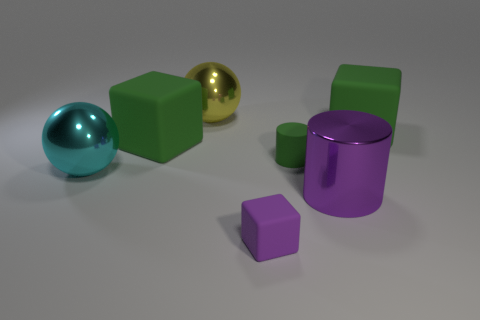There is a cube that is on the left side of the big shiny cylinder and behind the large cylinder; what is its color?
Your answer should be compact. Green. What number of green cylinders have the same size as the cyan metallic ball?
Ensure brevity in your answer.  0. What is the shape of the small thing that is behind the metallic object in front of the big cyan ball?
Make the answer very short. Cylinder. There is a large thing that is in front of the metallic ball that is in front of the green rubber object that is to the left of the small purple rubber thing; what shape is it?
Make the answer very short. Cylinder. How many other large purple things have the same shape as the purple shiny object?
Ensure brevity in your answer.  0. What number of tiny purple blocks are right of the matte cube to the left of the large yellow metal sphere?
Offer a very short reply. 1. How many rubber objects are either large yellow cubes or purple blocks?
Give a very brief answer. 1. Is there a tiny red block made of the same material as the tiny cylinder?
Your answer should be compact. No. How many objects are either rubber blocks that are to the right of the large cylinder or big green rubber blocks that are to the right of the small purple object?
Make the answer very short. 1. There is a tiny rubber object that is behind the purple cube; does it have the same color as the large cylinder?
Your answer should be compact. No. 